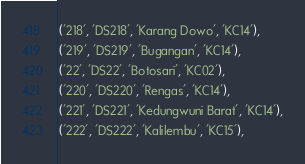<code> <loc_0><loc_0><loc_500><loc_500><_SQL_>('218', 'DS218', 'Karang Dowo', 'KC14'),
('219', 'DS219', 'Bugangan', 'KC14'),
('22', 'DS22', 'Botosari', 'KC02'),
('220', 'DS220', 'Rengas', 'KC14'),
('221', 'DS221', 'Kedungwuni Barat', 'KC14'),
('222', 'DS222', 'Kalilembu', 'KC15'),</code> 